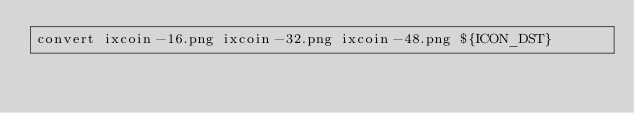Convert code to text. <code><loc_0><loc_0><loc_500><loc_500><_Bash_>convert ixcoin-16.png ixcoin-32.png ixcoin-48.png ${ICON_DST}

</code> 